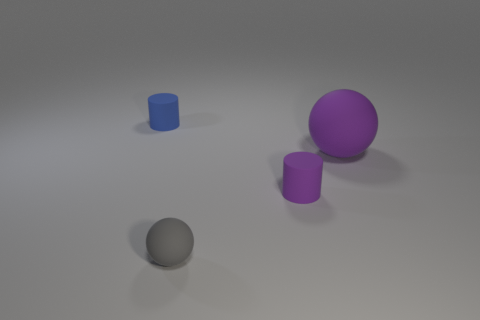There is a small cylinder that is the same color as the large rubber ball; what is it made of?
Offer a terse response. Rubber. There is a rubber ball in front of the purple matte cylinder; does it have the same size as the small blue cylinder?
Offer a terse response. Yes. Are there more big cyan cylinders than small blue cylinders?
Keep it short and to the point. No. How many tiny things are cylinders or blue objects?
Keep it short and to the point. 2. How many other objects are the same color as the large rubber thing?
Keep it short and to the point. 1. What number of purple spheres have the same material as the blue cylinder?
Give a very brief answer. 1. There is a small cylinder right of the small sphere; is its color the same as the large sphere?
Offer a terse response. Yes. What number of gray things are matte cylinders or tiny objects?
Give a very brief answer. 1. Does the purple object to the left of the big matte ball have the same material as the large purple ball?
Your answer should be very brief. Yes. What number of objects are either purple matte cylinders or things that are to the right of the gray rubber object?
Provide a short and direct response. 2. 